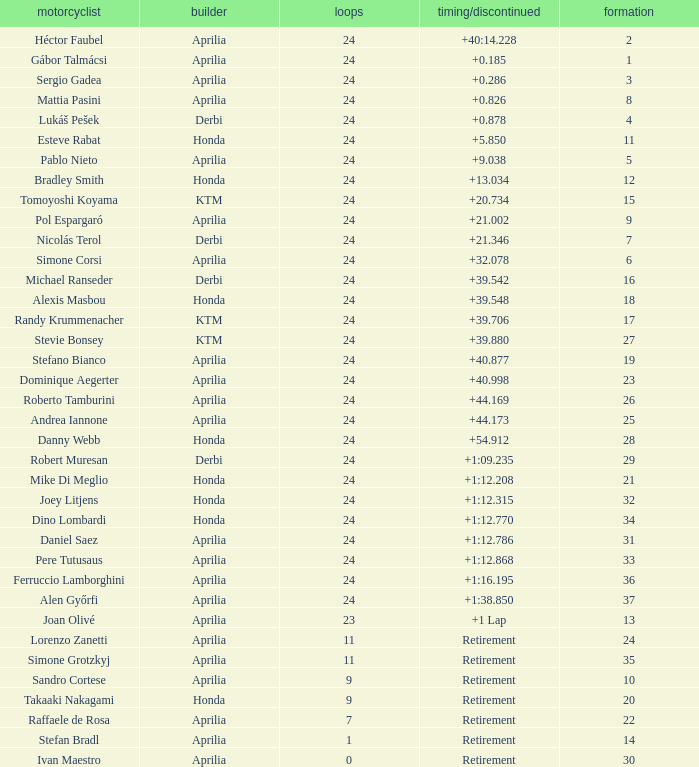What is the time with 10 grids? Retirement. 